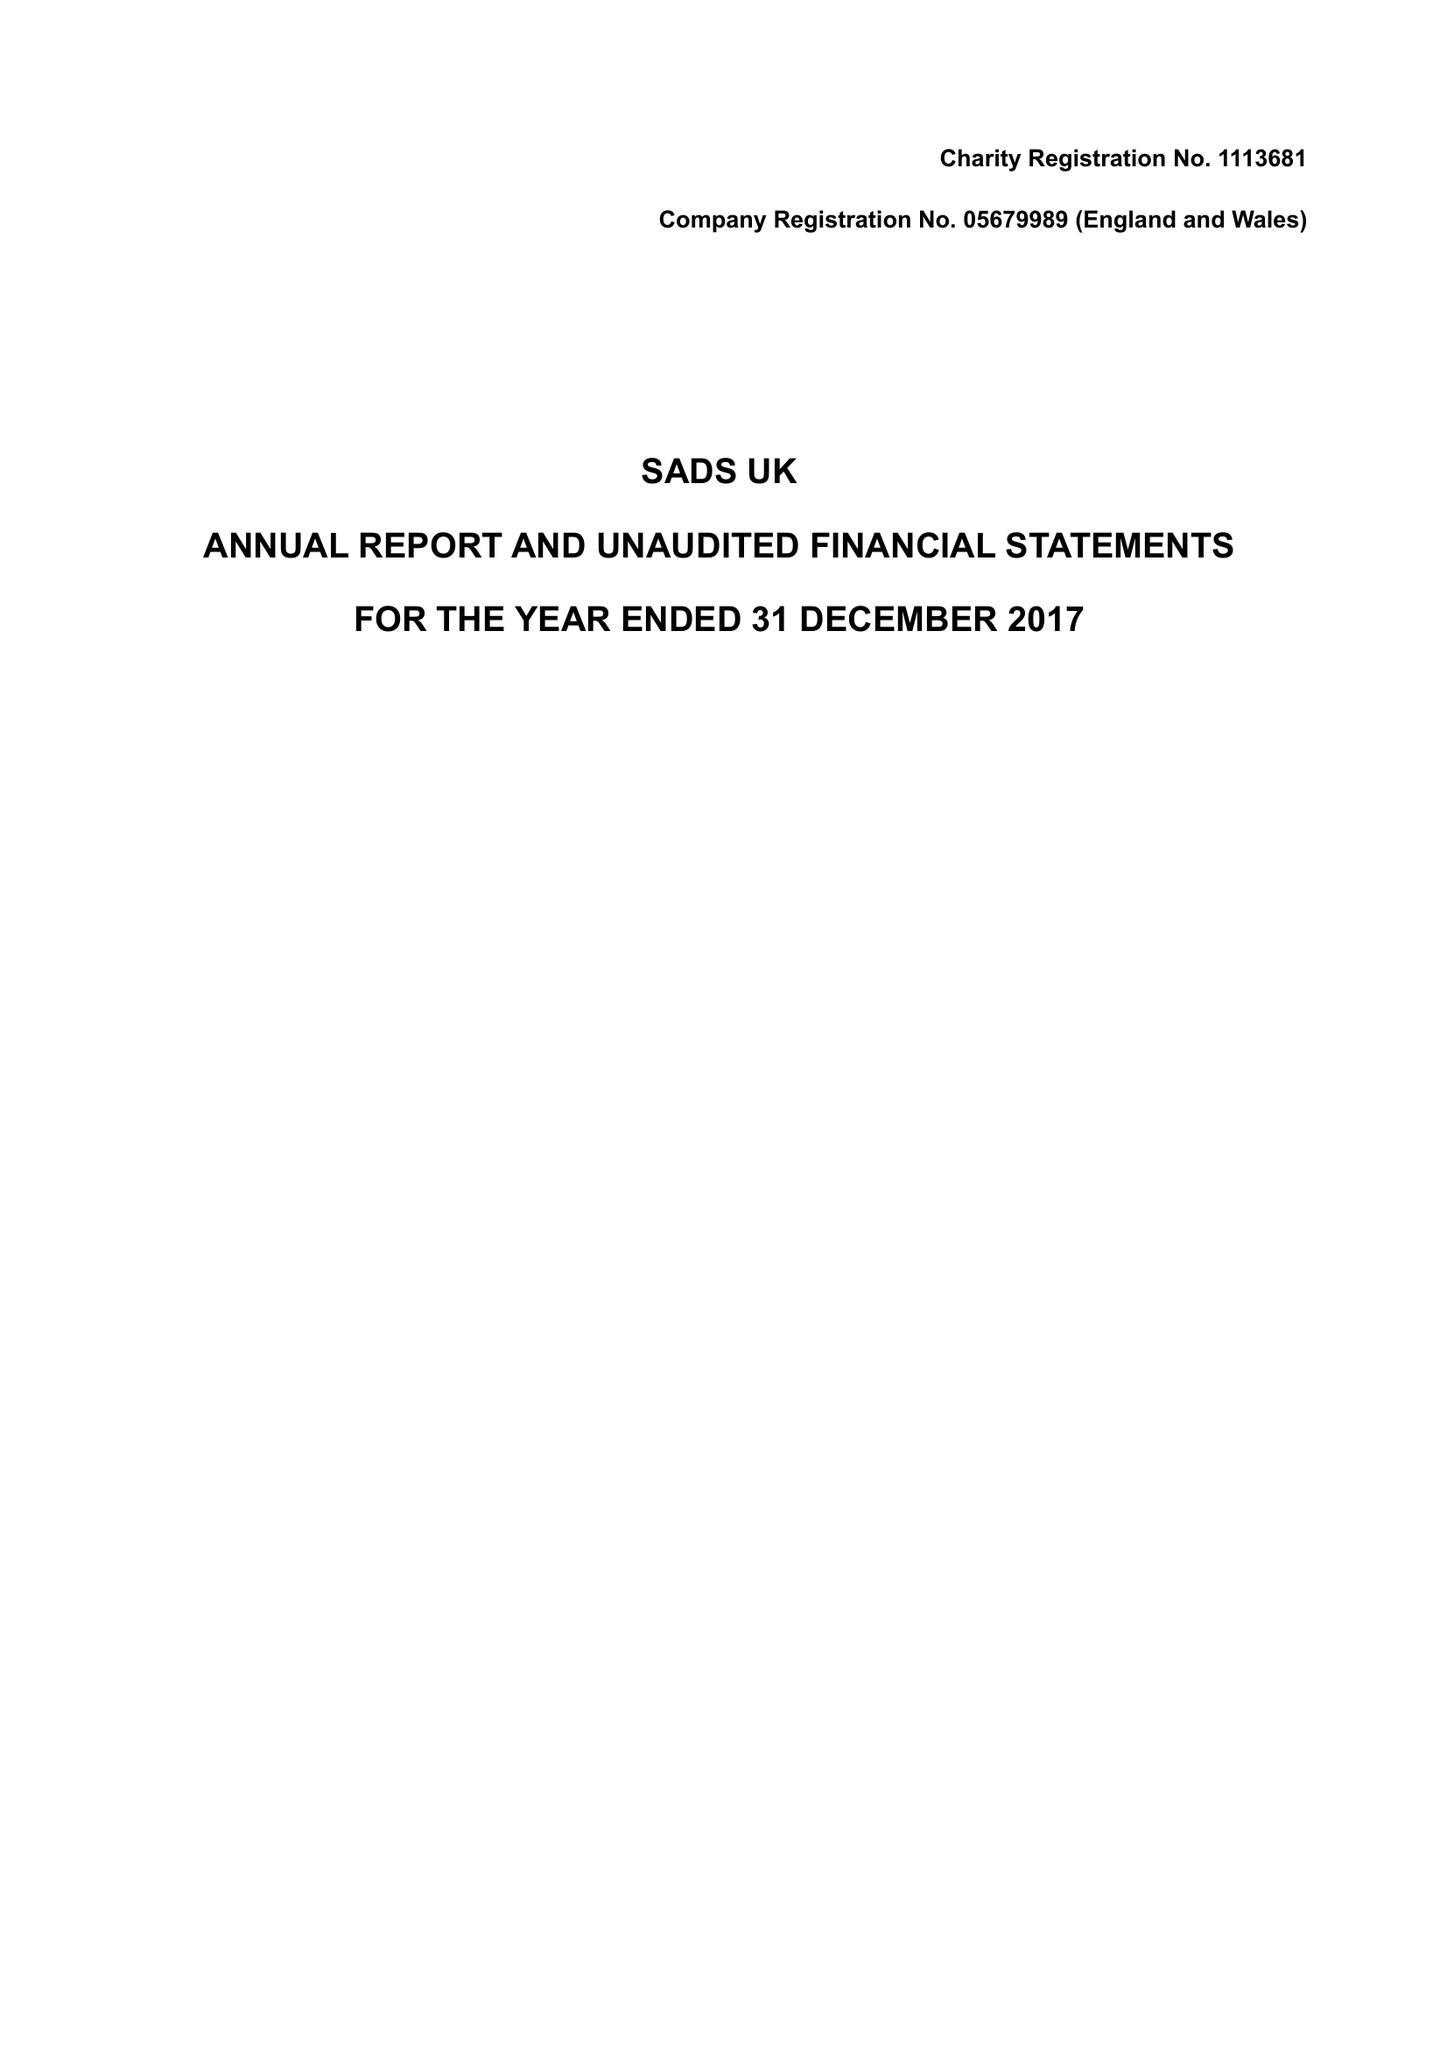What is the value for the income_annually_in_british_pounds?
Answer the question using a single word or phrase. 429386.00 